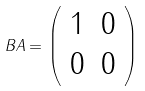<formula> <loc_0><loc_0><loc_500><loc_500>B A = { \left ( \begin{array} { l l } { 1 } & { 0 } \\ { 0 } & { 0 } \end{array} \right ) }</formula> 